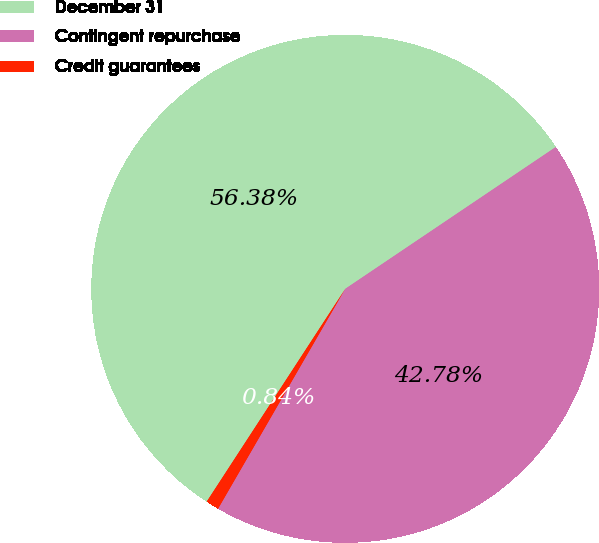Convert chart. <chart><loc_0><loc_0><loc_500><loc_500><pie_chart><fcel>December 31<fcel>Contingent repurchase<fcel>Credit guarantees<nl><fcel>56.38%<fcel>42.78%<fcel>0.84%<nl></chart> 